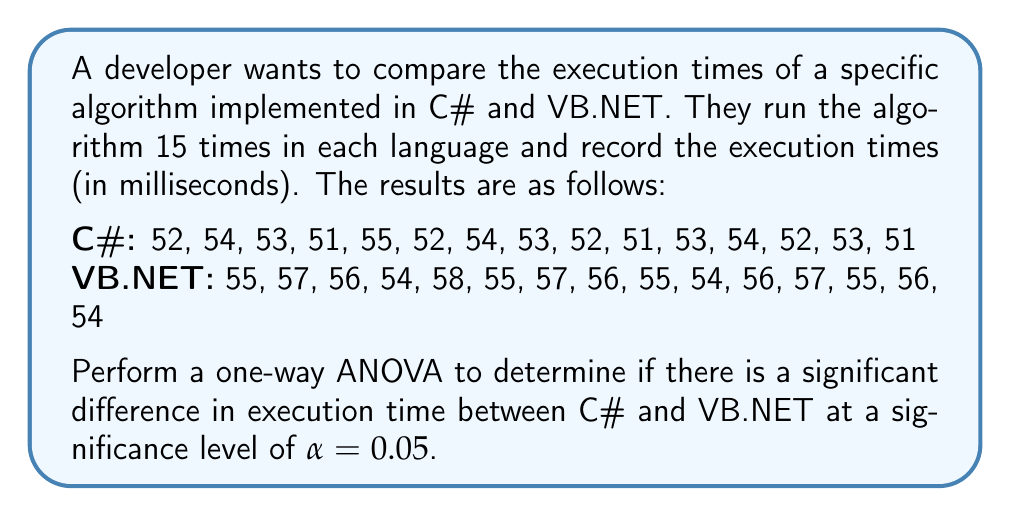Teach me how to tackle this problem. To perform a one-way ANOVA, we'll follow these steps:

1. Calculate the sum of squares between groups (SSB) and within groups (SSW).
2. Calculate the degrees of freedom for between groups (dfB) and within groups (dfW).
3. Calculate the mean squares between groups (MSB) and within groups (MSW).
4. Calculate the F-statistic.
5. Compare the F-statistic to the critical F-value.

Step 1: Calculate SSB and SSW

First, we need to calculate the means for each group and the overall mean:

C# mean: $\bar{X}_1 = 52.67$
VB.NET mean: $\bar{X}_2 = 55.67$
Overall mean: $\bar{X} = 54.17$

Now we can calculate SSB:
$$SSB = n_1(\bar{X}_1 - \bar{X})^2 + n_2(\bar{X}_2 - \bar{X})^2$$
$$SSB = 15(52.67 - 54.17)^2 + 15(55.67 - 54.17)^2 = 67.50$$

For SSW, we calculate the sum of squared deviations from each group mean:

$$SSW = \sum_{i=1}^{n_1} (X_{1i} - \bar{X}_1)^2 + \sum_{i=1}^{n_2} (X_{2i} - \bar{X}_2)^2 = 32.00 + 32.00 = 64.00$$

Step 2: Calculate degrees of freedom

dfB = number of groups - 1 = 2 - 1 = 1
dfW = total number of observations - number of groups = 30 - 2 = 28

Step 3: Calculate mean squares

$$MSB = \frac{SSB}{dfB} = \frac{67.50}{1} = 67.50$$
$$MSW = \frac{SSW}{dfW} = \frac{64.00}{28} = 2.29$$

Step 4: Calculate F-statistic

$$F = \frac{MSB}{MSW} = \frac{67.50}{2.29} = 29.52$$

Step 5: Compare F-statistic to critical F-value

The critical F-value for α = 0.05, dfB = 1, and dfW = 28 is approximately 4.20.

Since our calculated F-statistic (29.52) is greater than the critical F-value (4.20), we reject the null hypothesis.
Answer: There is a significant difference in execution time between C# and VB.NET for the specific algorithm at a significance level of α = 0.05 (F(1, 28) = 29.52, p < 0.05). 